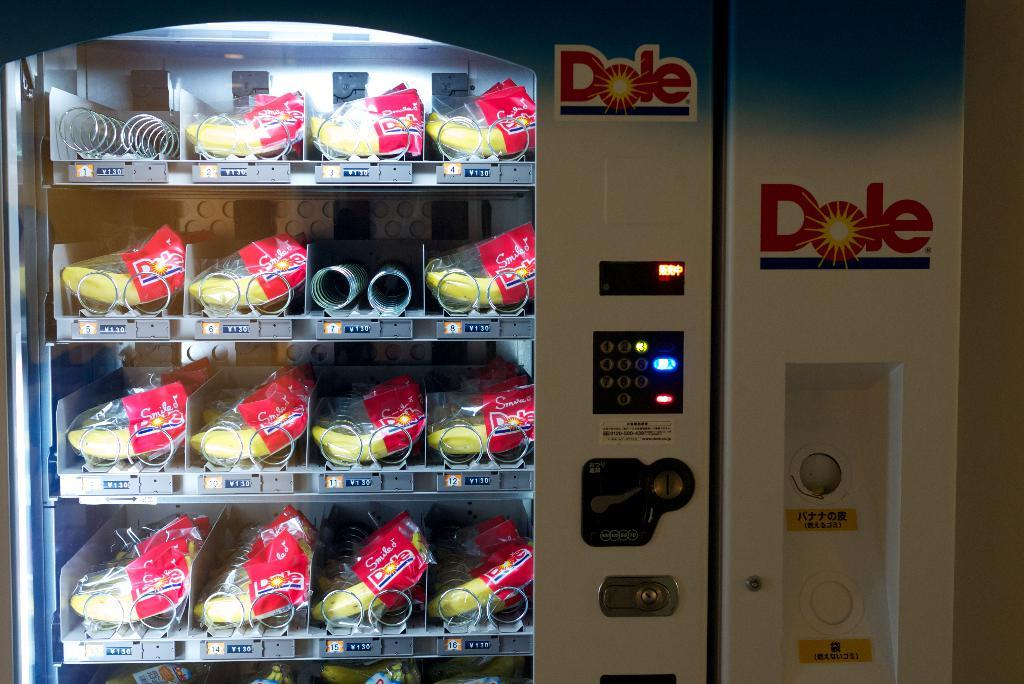<image>
Create a compact narrative representing the image presented. A Dole vending machine dispenses wrapped bananas only. 